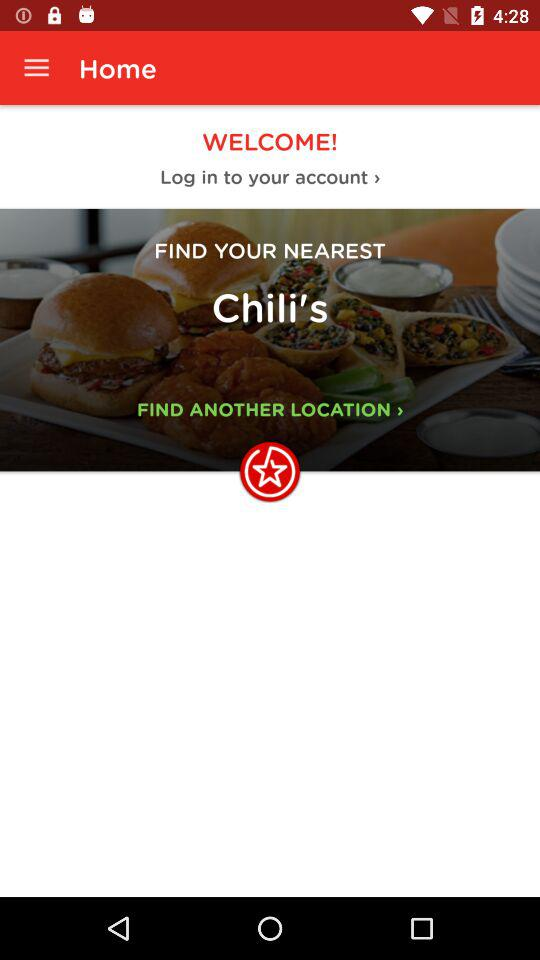What's to be found nearest? The nearest find is Chili's. 